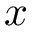<formula> <loc_0><loc_0><loc_500><loc_500>x</formula> 